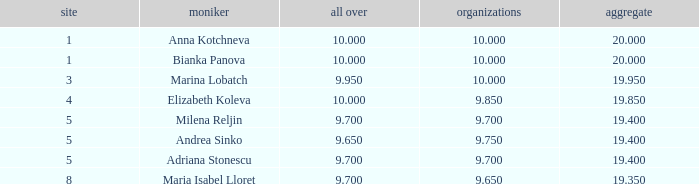What is the highest total that has andrea sinko as the name, with an all around greater than 9.65? None. 